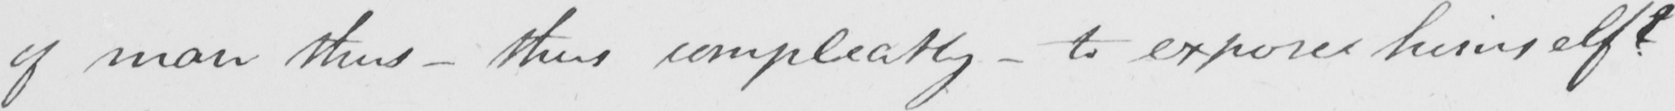What text is written in this handwritten line? of man thus  _  thus compleatly  _  to expose himself  ? 